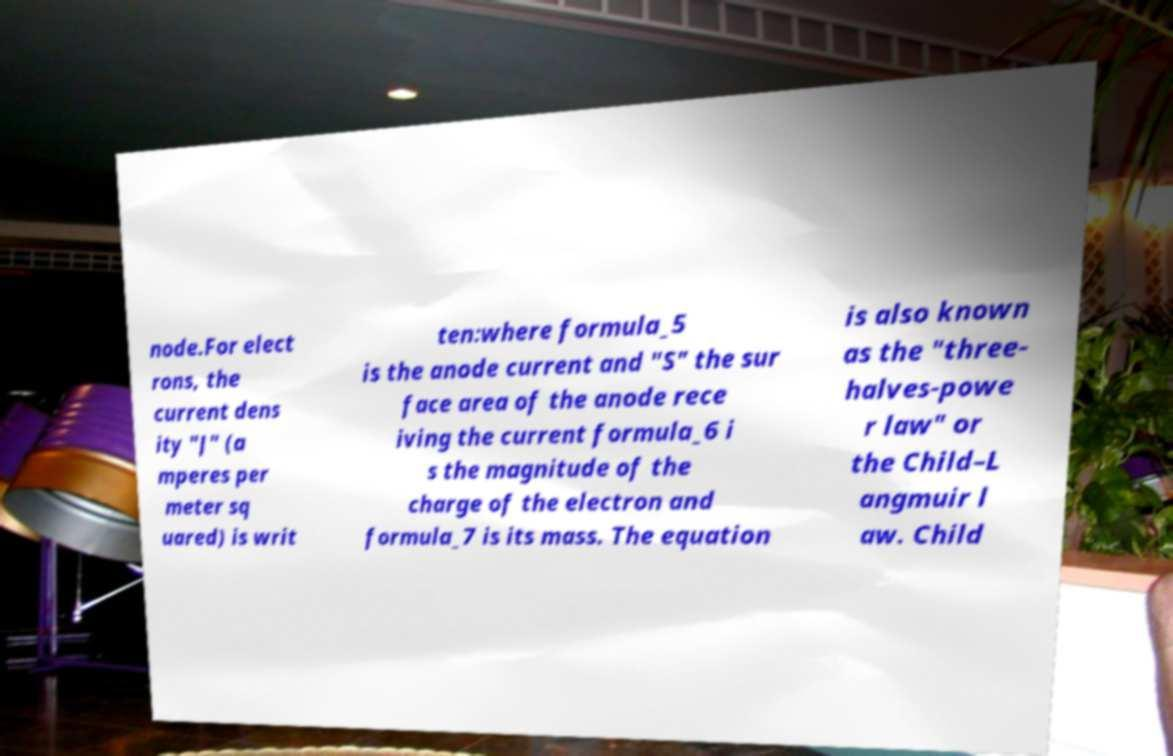Please read and relay the text visible in this image. What does it say? node.For elect rons, the current dens ity "J" (a mperes per meter sq uared) is writ ten:where formula_5 is the anode current and "S" the sur face area of the anode rece iving the current formula_6 i s the magnitude of the charge of the electron and formula_7 is its mass. The equation is also known as the "three- halves-powe r law" or the Child–L angmuir l aw. Child 